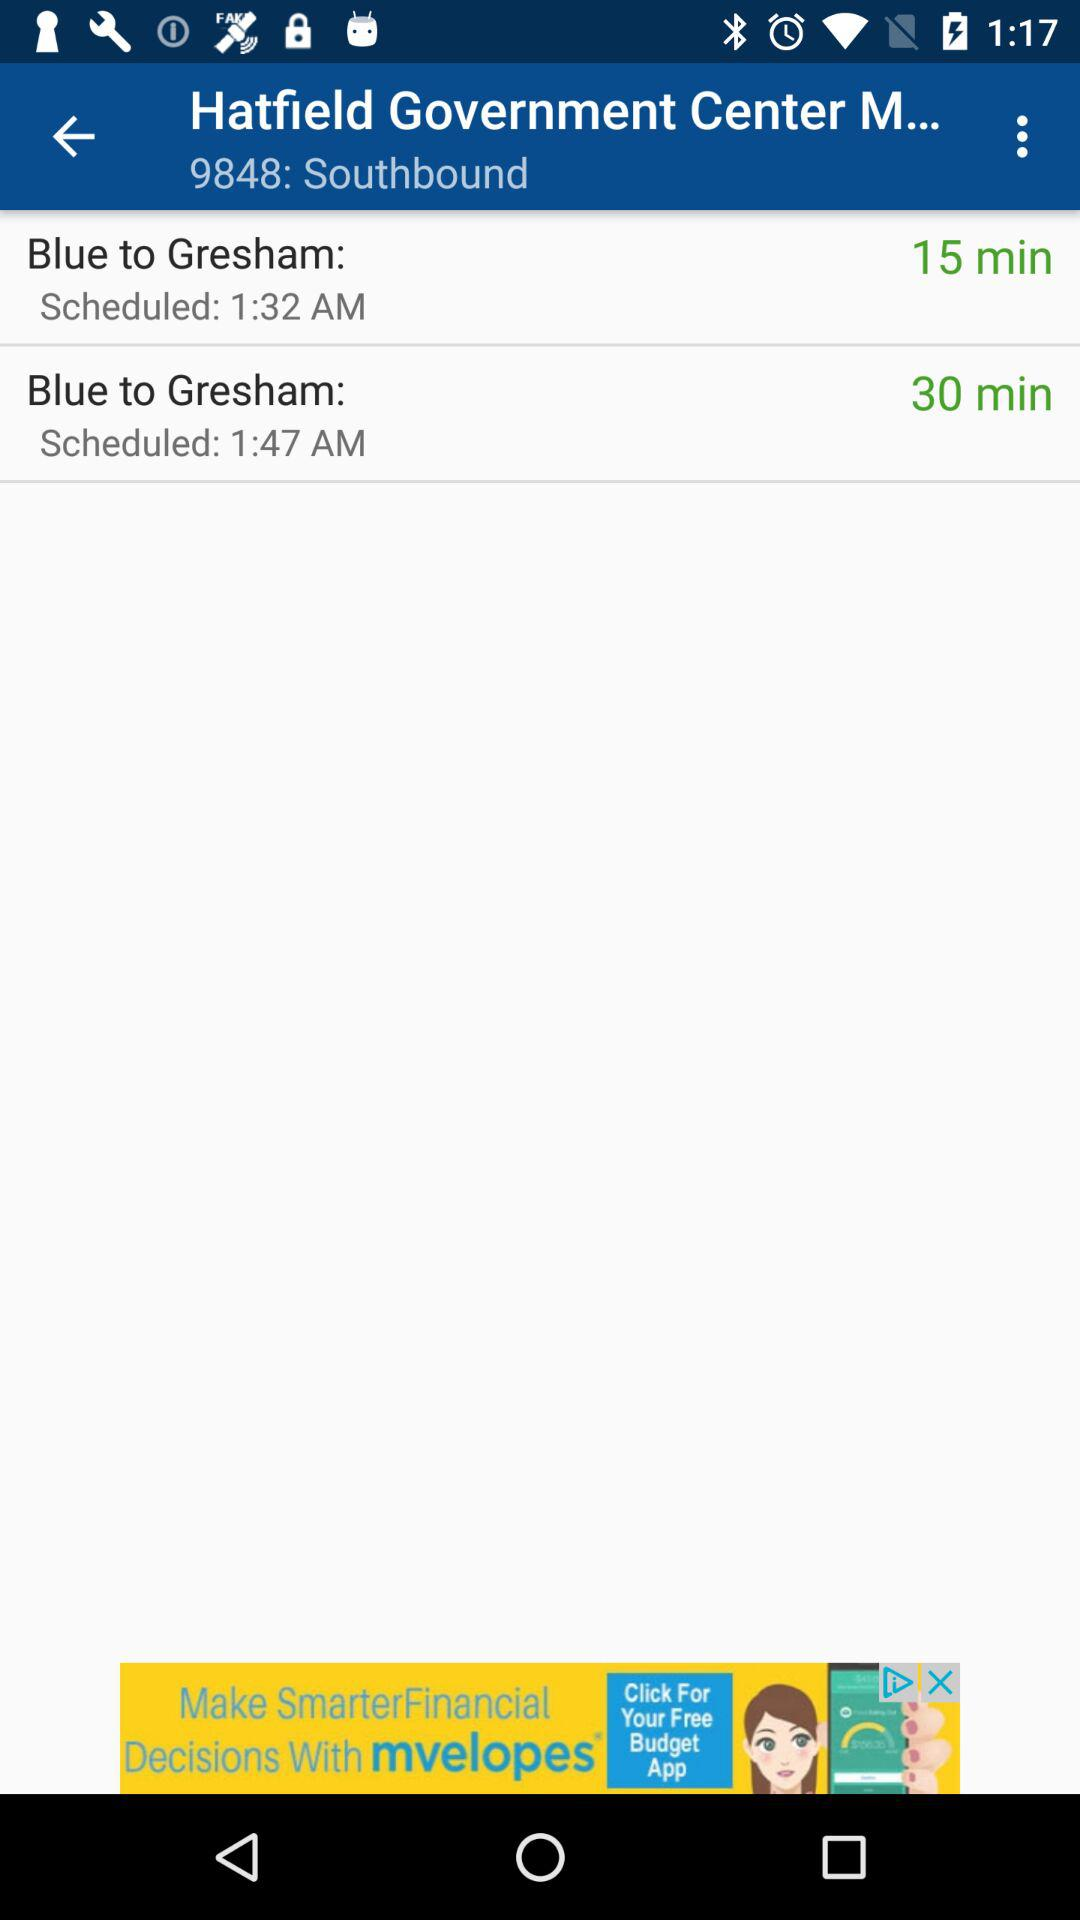How many minutes later is the second bus scheduled than the first?
Answer the question using a single word or phrase. 15 